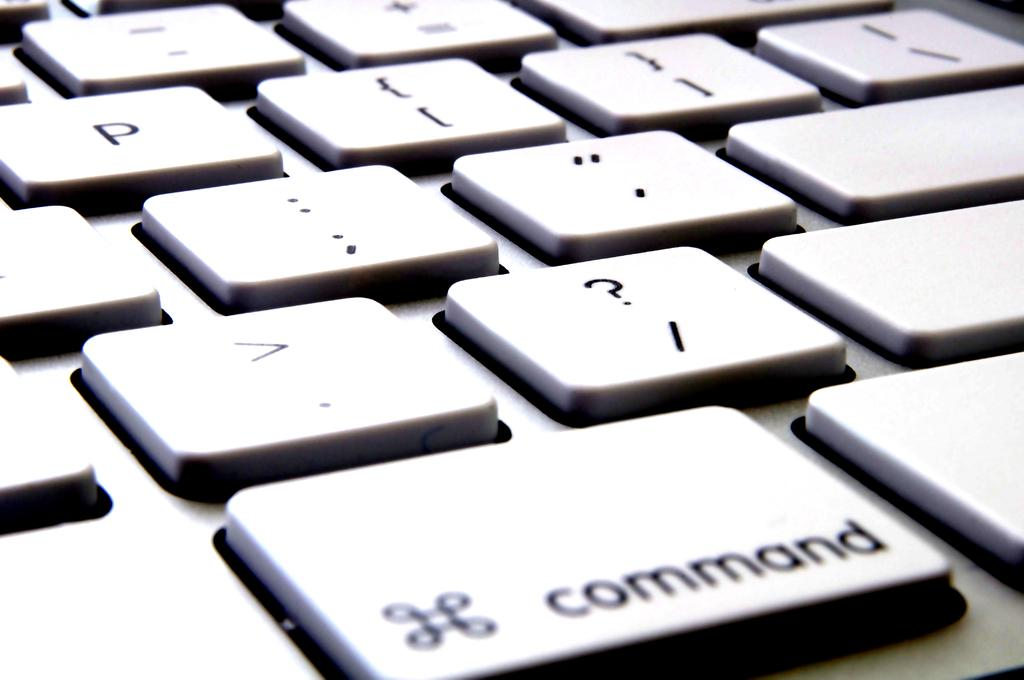<image>
Relay a brief, clear account of the picture shown. The command key is the largest key in this photo of a keyboard. 